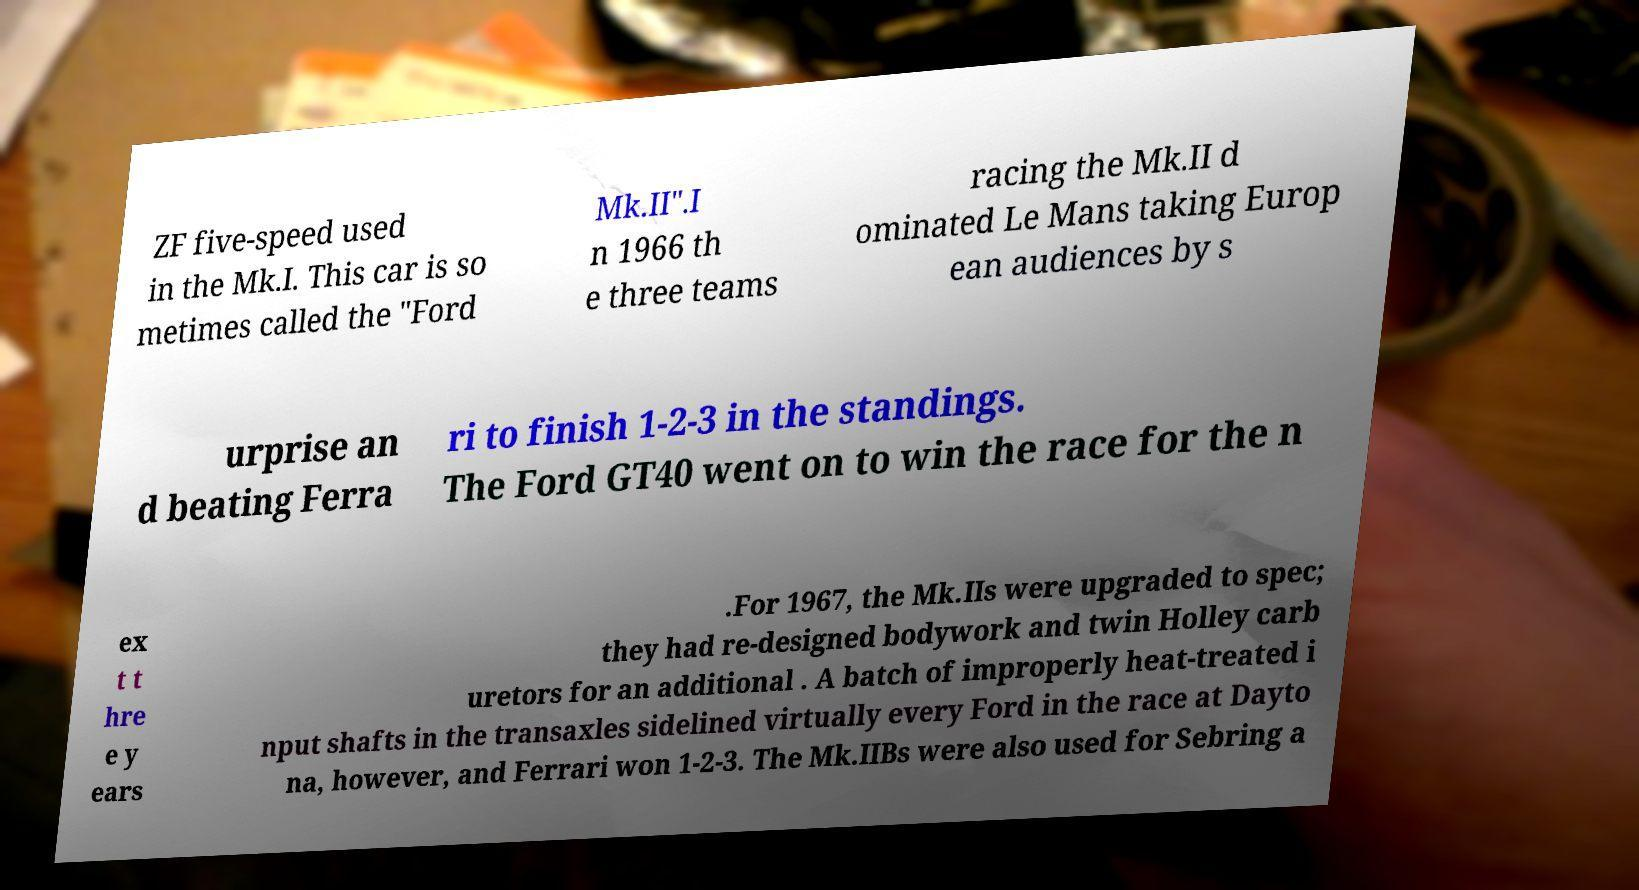Please read and relay the text visible in this image. What does it say? ZF five-speed used in the Mk.I. This car is so metimes called the "Ford Mk.II".I n 1966 th e three teams racing the Mk.II d ominated Le Mans taking Europ ean audiences by s urprise an d beating Ferra ri to finish 1-2-3 in the standings. The Ford GT40 went on to win the race for the n ex t t hre e y ears .For 1967, the Mk.IIs were upgraded to spec; they had re-designed bodywork and twin Holley carb uretors for an additional . A batch of improperly heat-treated i nput shafts in the transaxles sidelined virtually every Ford in the race at Dayto na, however, and Ferrari won 1-2-3. The Mk.IIBs were also used for Sebring a 